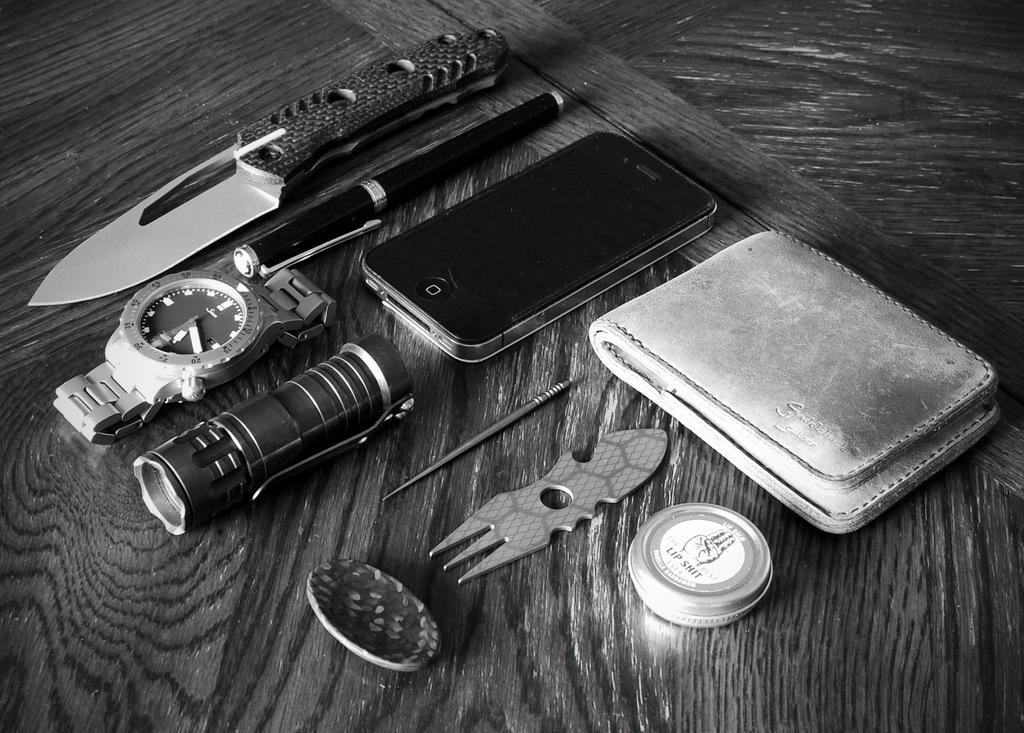Provide a one-sentence caption for the provided image. A collection of things including a tin of lip balm that says lip shit on it. 